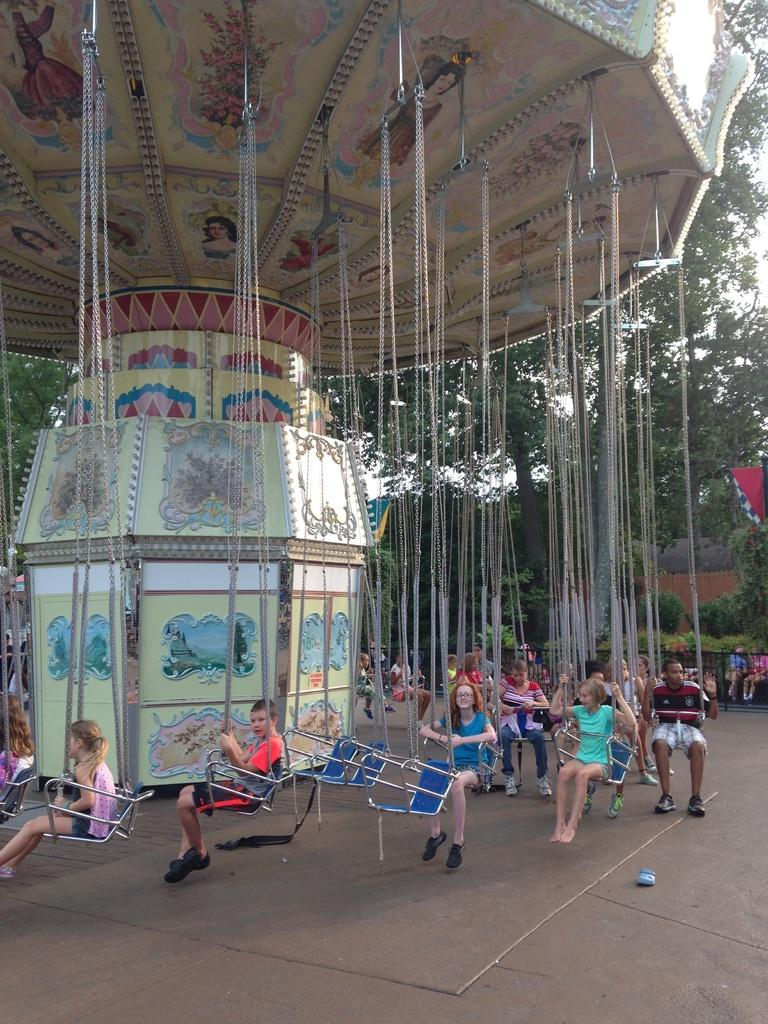What is the main subject of the image? The main subject of the image is a group of kids. What are the kids doing in the image? The kids are sitting on a child carousel. What can be seen in the background of the image? There are trees in the background of the image. What type of fuel is being used to power the child carousel in the image? There is no indication in the image of the child carousel being powered by any type of fuel. 